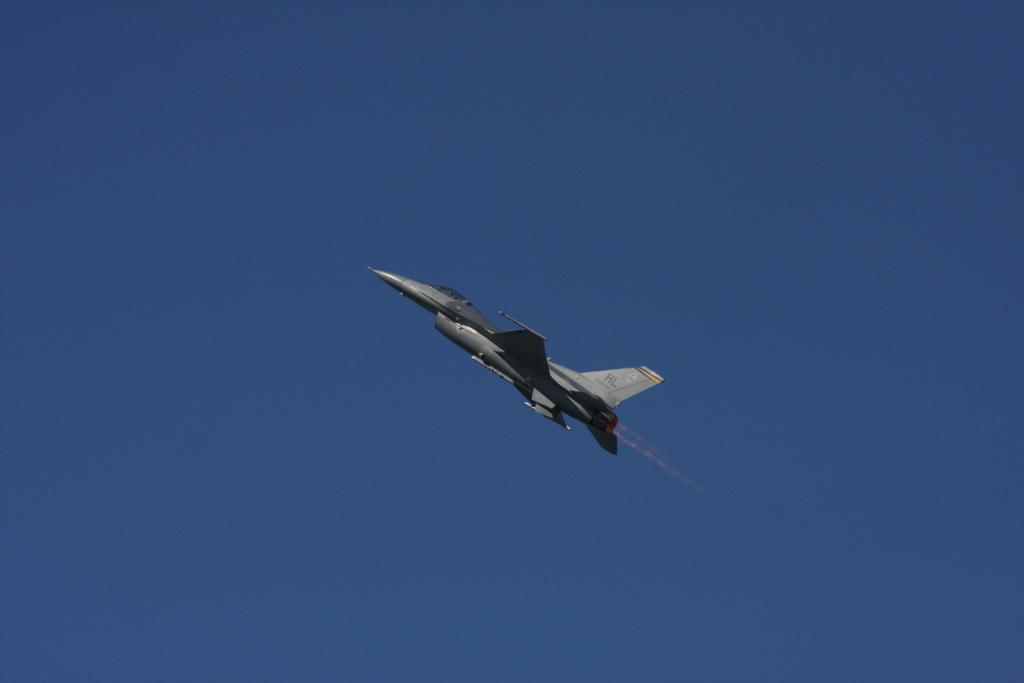What is the main subject of the image? The main subject of the image is an aircraft. Can you describe the position of the aircraft in the image? The aircraft is in the air in the image. What can be seen in the background of the image? The sky is visible in the background of the image. What type of baseball game is being played in the image? There is no baseball game present in the image; it features an aircraft in the air. Can you see any fairies flying around the aircraft in the image? There are no fairies present in the image; it only shows an aircraft in the air. 